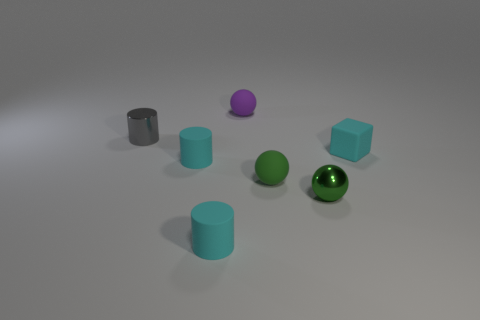Subtract all blue balls. How many cyan cylinders are left? 2 Subtract all matte spheres. How many spheres are left? 1 Add 3 tiny metal cylinders. How many objects exist? 10 Subtract all green cylinders. Subtract all green blocks. How many cylinders are left? 3 Subtract 0 red balls. How many objects are left? 7 Subtract all cylinders. How many objects are left? 4 Subtract all tiny blue rubber things. Subtract all tiny cyan cubes. How many objects are left? 6 Add 2 cyan objects. How many cyan objects are left? 5 Add 5 tiny cyan rubber cubes. How many tiny cyan rubber cubes exist? 6 